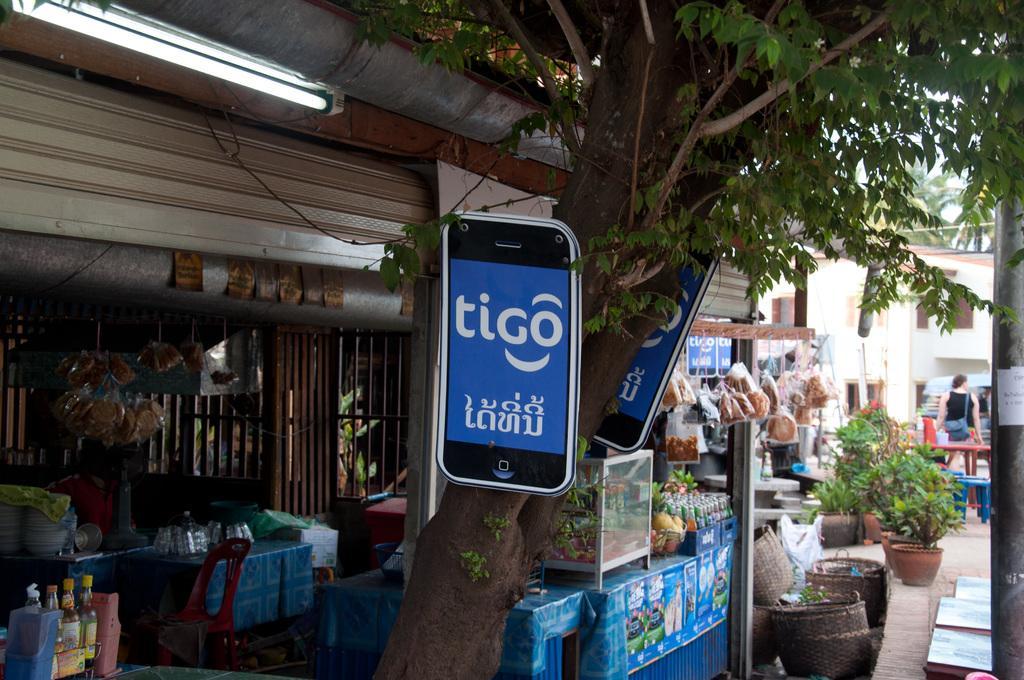Could you give a brief overview of what you see in this image? In this picture on the right side, we can see a pole and a woman is wearing a back pack and standing behind the table, flower pot, plant, buildings. In the middle, we can also see a tree, mobile. On the left side, there is a stall, table, chairs, tube light. 